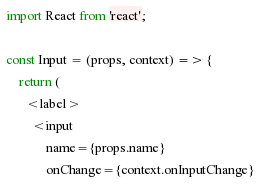<code> <loc_0><loc_0><loc_500><loc_500><_JavaScript_>import React from 'react';

const Input = (props, context) => {
	return (
      <label>
        <input
        	name={props.name}
        	onChange={context.onInputChange}</code> 